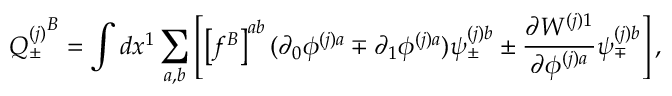Convert formula to latex. <formula><loc_0><loc_0><loc_500><loc_500>{ Q _ { \pm } ^ { ( j ) } } ^ { B } = \int d x ^ { 1 } \sum _ { a , b } \left [ \left [ f ^ { B } \right ] ^ { a b } ( \partial _ { 0 } \phi ^ { ( j ) a } \mp \partial _ { 1 } \phi ^ { ( j ) a } ) \psi _ { \pm } ^ { ( j ) b } \pm \frac { \partial W ^ { ( j ) 1 } } { \partial \phi ^ { ( j ) a } } \psi _ { \mp } ^ { ( j ) b } \right ] ,</formula> 